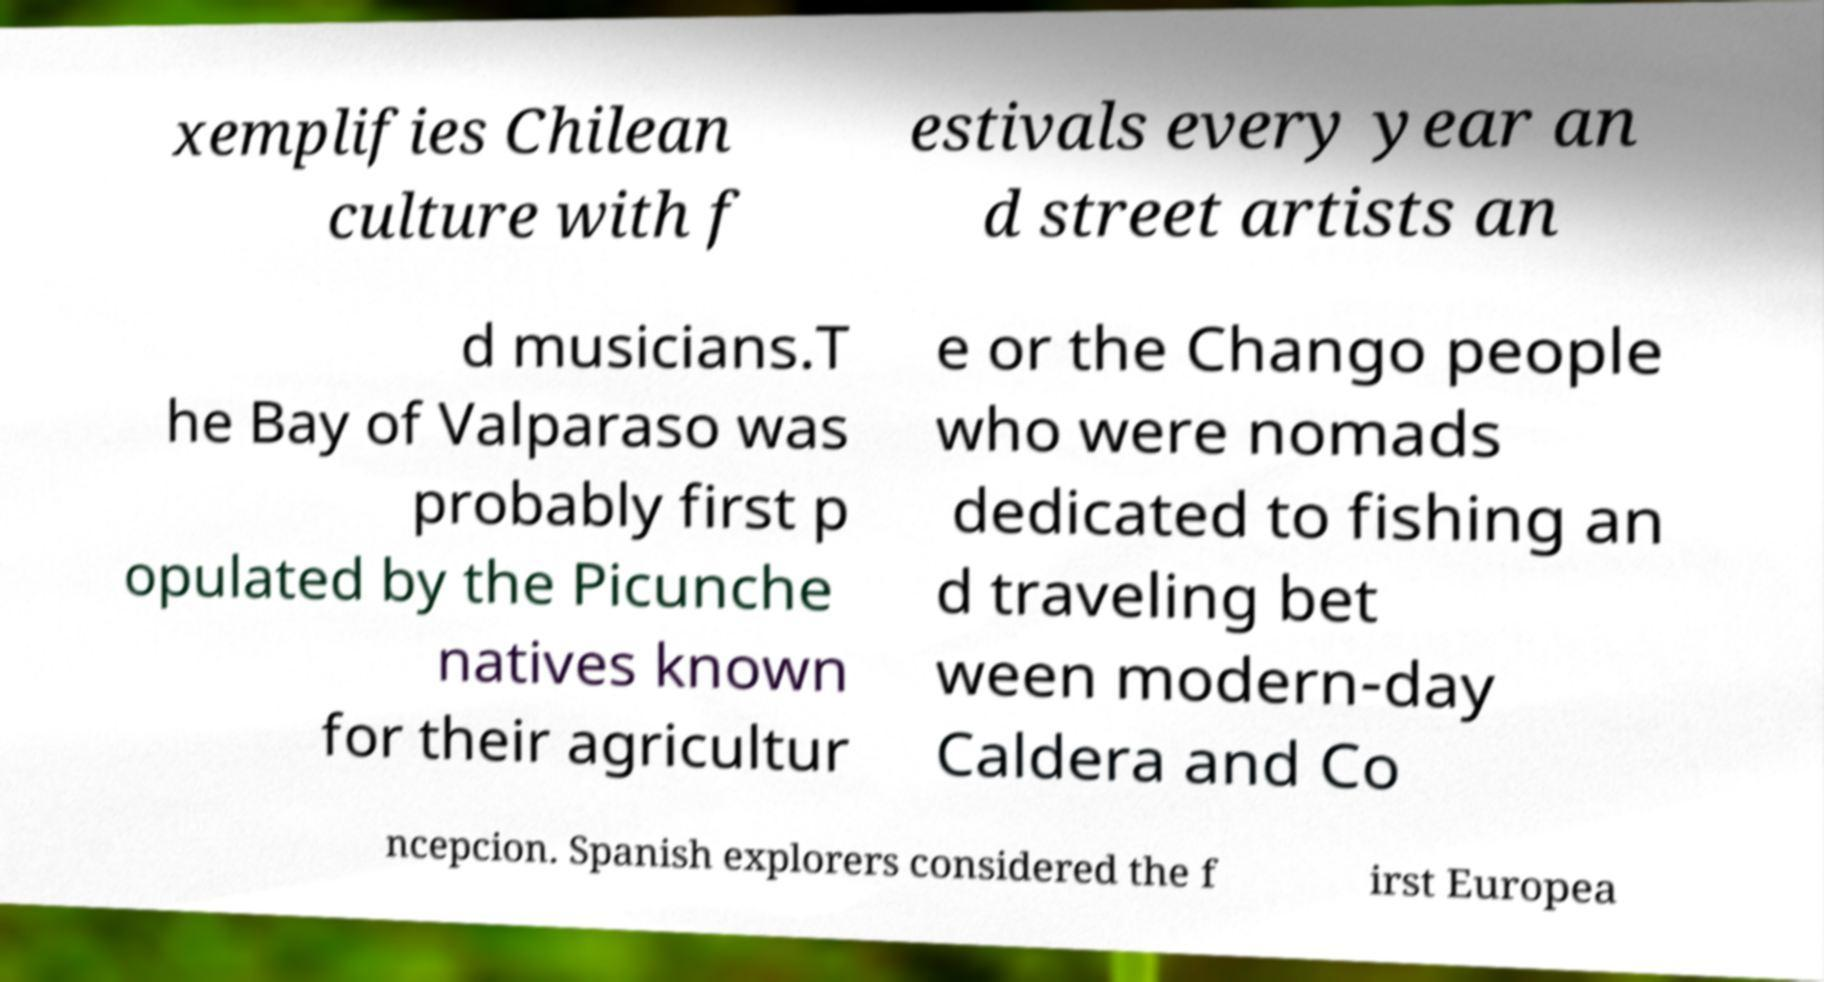Could you assist in decoding the text presented in this image and type it out clearly? xemplifies Chilean culture with f estivals every year an d street artists an d musicians.T he Bay of Valparaso was probably first p opulated by the Picunche natives known for their agricultur e or the Chango people who were nomads dedicated to fishing an d traveling bet ween modern-day Caldera and Co ncepcion. Spanish explorers considered the f irst Europea 